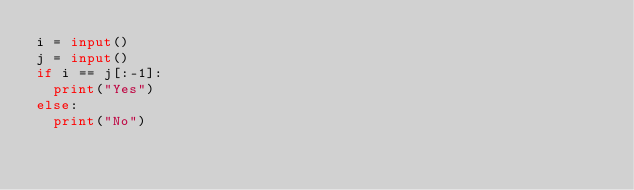<code> <loc_0><loc_0><loc_500><loc_500><_Python_>i = input()
j = input()
if i == j[:-1]:
  print("Yes")
else:
  print("No")</code> 